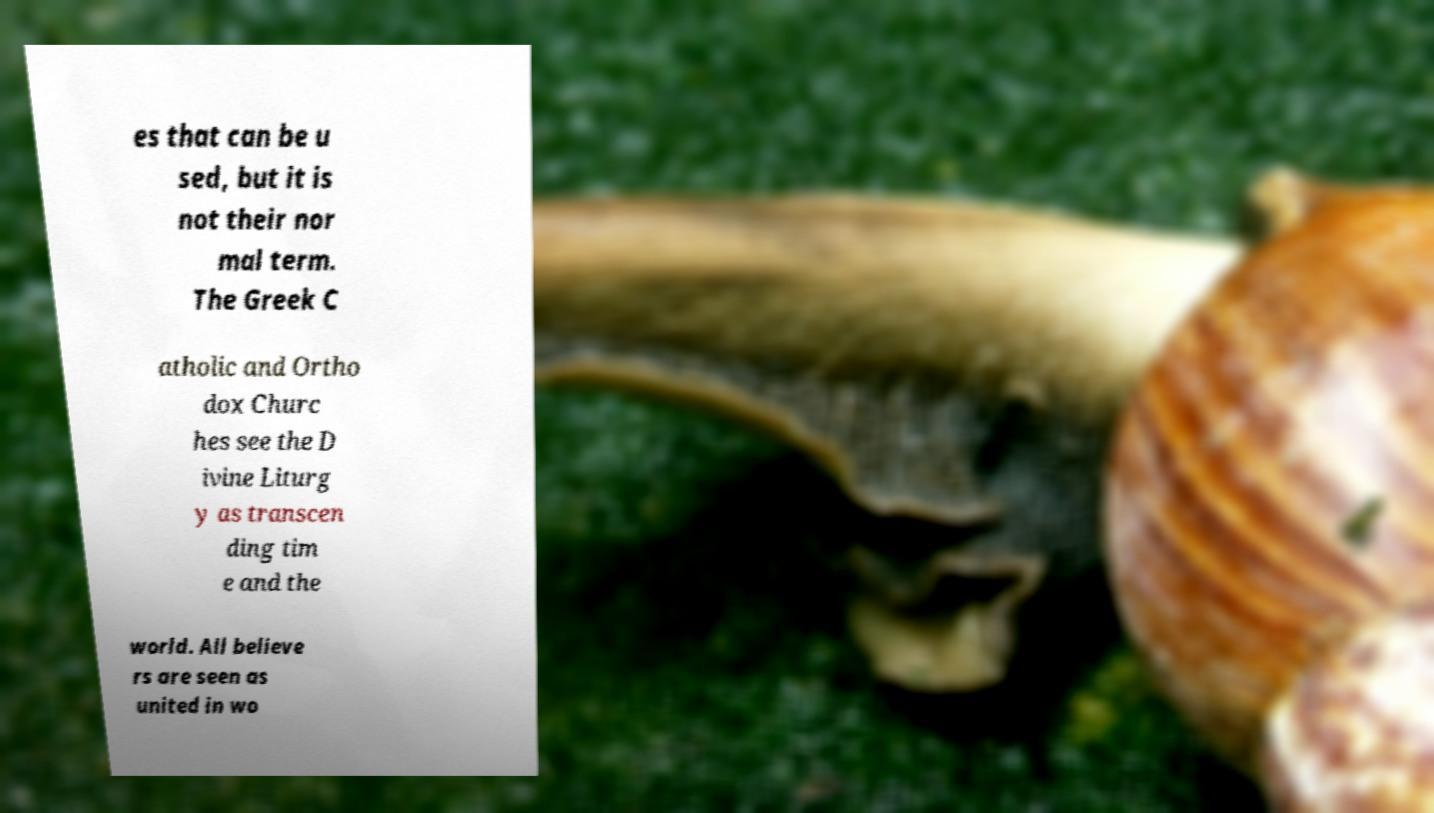There's text embedded in this image that I need extracted. Can you transcribe it verbatim? es that can be u sed, but it is not their nor mal term. The Greek C atholic and Ortho dox Churc hes see the D ivine Liturg y as transcen ding tim e and the world. All believe rs are seen as united in wo 